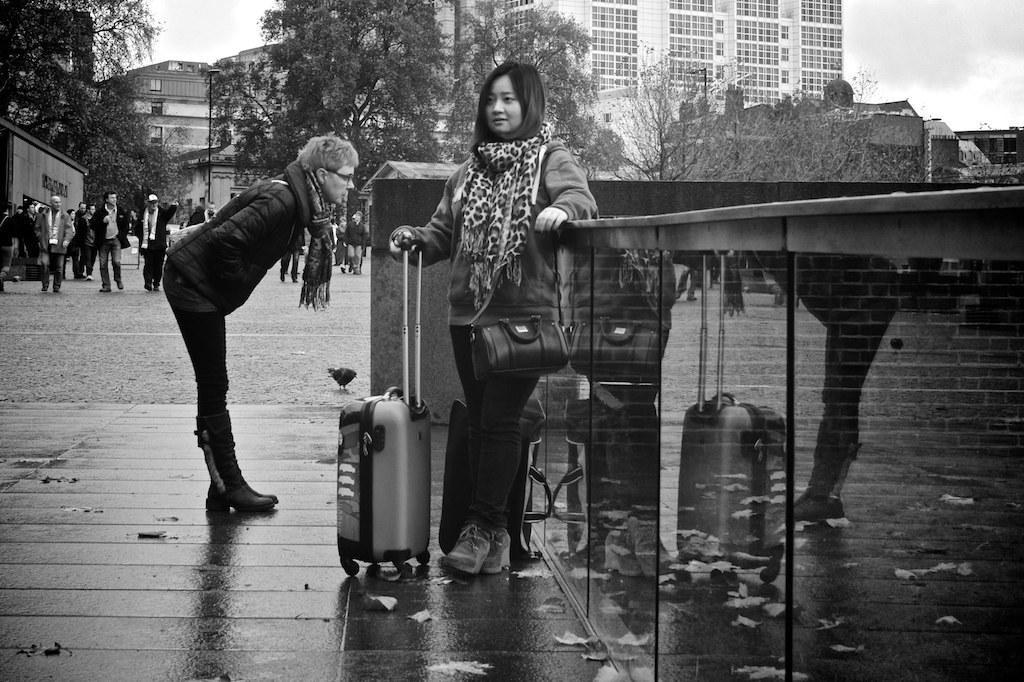In one or two sentences, can you explain what this image depicts? In this picture couple of them standing and I can see a woman holding a trolley bag and I can see few people walking in the back. I can see trees, buildings and a cloudy sky. 